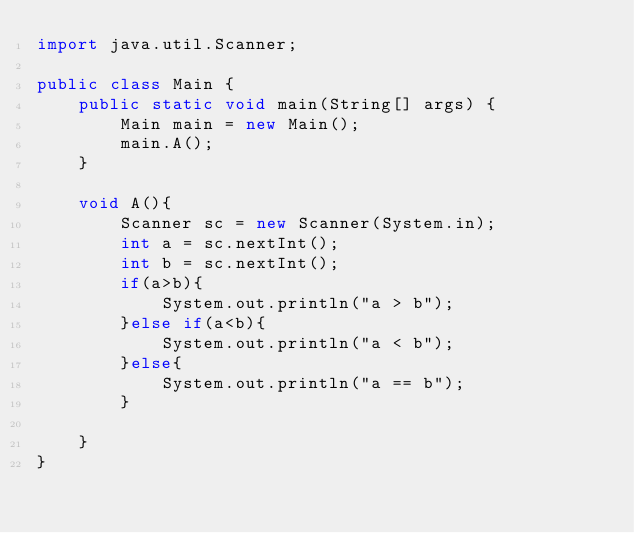<code> <loc_0><loc_0><loc_500><loc_500><_Java_>import java.util.Scanner;

public class Main {
	public static void main(String[] args) {
		Main main = new Main();
		main.A();
	}
	
	void A(){
		Scanner sc = new Scanner(System.in);
		int a = sc.nextInt();
		int b = sc.nextInt();
		if(a>b){
			System.out.println("a > b");
		}else if(a<b){
			System.out.println("a < b");
		}else{
			System.out.println("a == b");
		}
		
	}
}</code> 